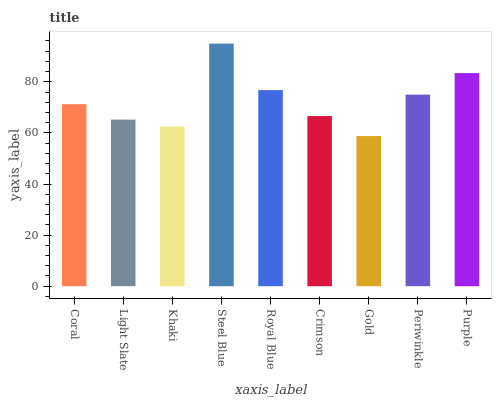Is Gold the minimum?
Answer yes or no. Yes. Is Steel Blue the maximum?
Answer yes or no. Yes. Is Light Slate the minimum?
Answer yes or no. No. Is Light Slate the maximum?
Answer yes or no. No. Is Coral greater than Light Slate?
Answer yes or no. Yes. Is Light Slate less than Coral?
Answer yes or no. Yes. Is Light Slate greater than Coral?
Answer yes or no. No. Is Coral less than Light Slate?
Answer yes or no. No. Is Coral the high median?
Answer yes or no. Yes. Is Coral the low median?
Answer yes or no. Yes. Is Gold the high median?
Answer yes or no. No. Is Steel Blue the low median?
Answer yes or no. No. 